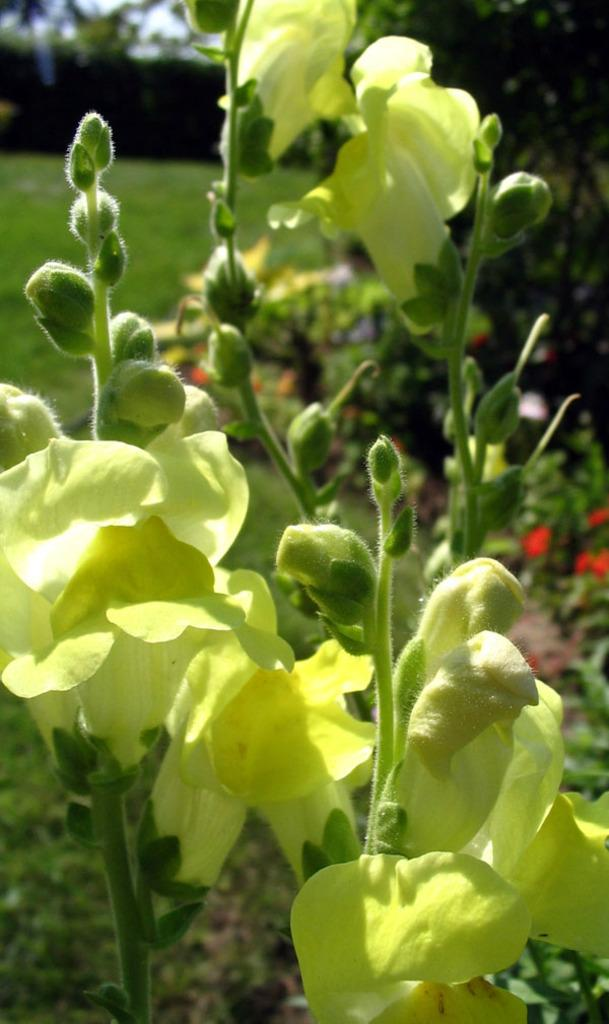What type of living organisms can be seen in the image? Plants can be seen in the image. Do the plants have any specific features? Yes, the plants have flowers. What type of vegetation is visible in the image? Grass is visible in the image. Can you tell me how many goldfish are swimming in the water in the image? There is no water or goldfish present in the image; it features plants with flowers and grass. 